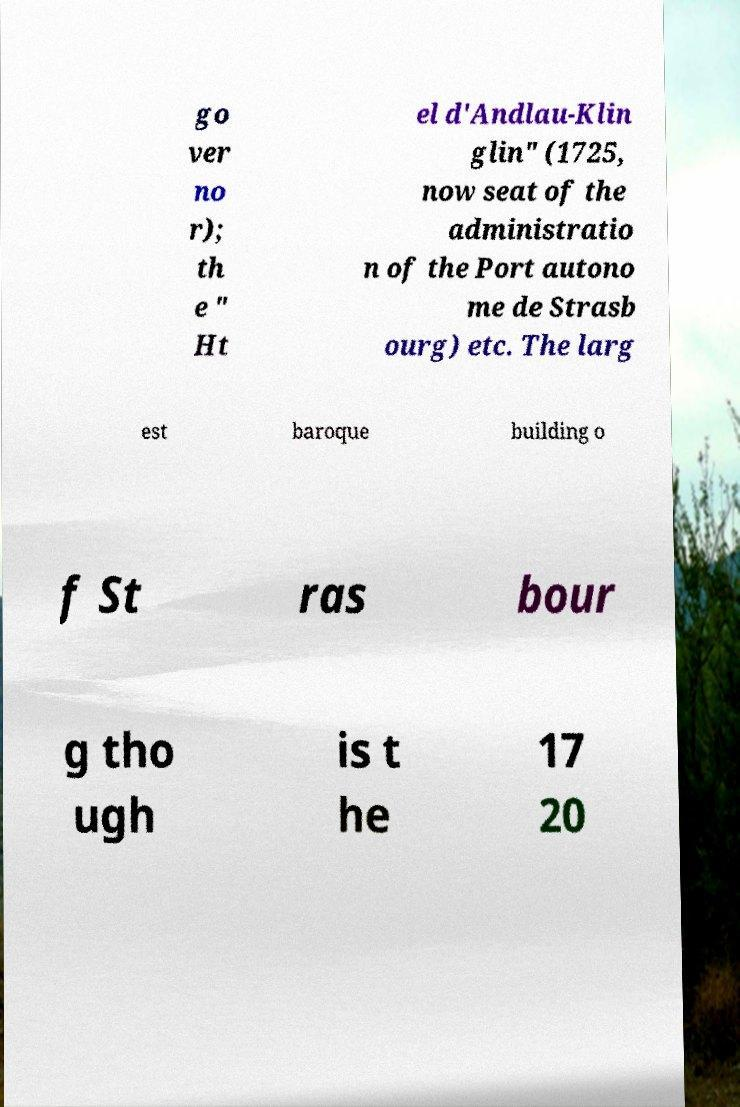I need the written content from this picture converted into text. Can you do that? go ver no r); th e " Ht el d'Andlau-Klin glin" (1725, now seat of the administratio n of the Port autono me de Strasb ourg) etc. The larg est baroque building o f St ras bour g tho ugh is t he 17 20 